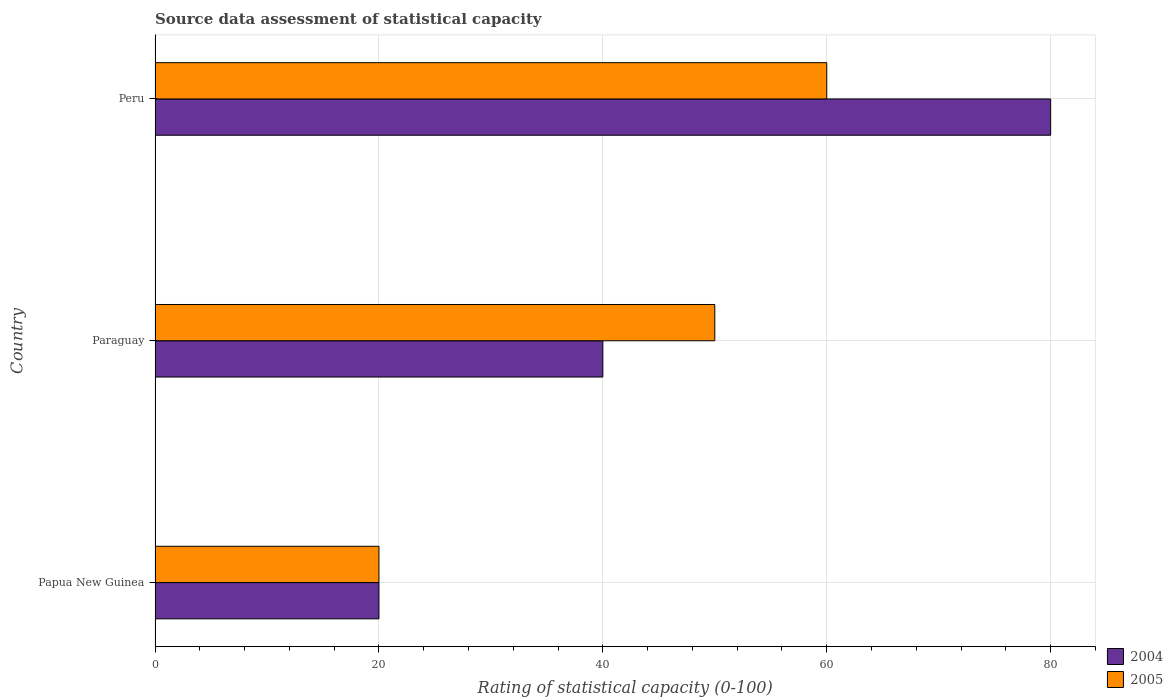How many different coloured bars are there?
Provide a succinct answer. 2. How many groups of bars are there?
Keep it short and to the point. 3. Are the number of bars on each tick of the Y-axis equal?
Your answer should be very brief. Yes. How many bars are there on the 2nd tick from the bottom?
Offer a terse response. 2. In how many cases, is the number of bars for a given country not equal to the number of legend labels?
Give a very brief answer. 0. What is the rating of statistical capacity in 2004 in Peru?
Offer a terse response. 80. Across all countries, what is the maximum rating of statistical capacity in 2005?
Offer a terse response. 60. In which country was the rating of statistical capacity in 2005 minimum?
Offer a very short reply. Papua New Guinea. What is the total rating of statistical capacity in 2005 in the graph?
Ensure brevity in your answer.  130. What is the difference between the rating of statistical capacity in 2004 in Papua New Guinea and that in Peru?
Provide a short and direct response. -60. What is the difference between the rating of statistical capacity in 2005 in Paraguay and the rating of statistical capacity in 2004 in Papua New Guinea?
Make the answer very short. 30. What is the average rating of statistical capacity in 2005 per country?
Offer a terse response. 43.33. What is the ratio of the rating of statistical capacity in 2005 in Paraguay to that in Peru?
Make the answer very short. 0.83. What is the difference between the highest and the second highest rating of statistical capacity in 2005?
Your answer should be compact. 10. In how many countries, is the rating of statistical capacity in 2004 greater than the average rating of statistical capacity in 2004 taken over all countries?
Make the answer very short. 1. What does the 1st bar from the bottom in Paraguay represents?
Provide a succinct answer. 2004. How many bars are there?
Make the answer very short. 6. What is the difference between two consecutive major ticks on the X-axis?
Ensure brevity in your answer.  20. Are the values on the major ticks of X-axis written in scientific E-notation?
Your response must be concise. No. Does the graph contain any zero values?
Your response must be concise. No. Where does the legend appear in the graph?
Provide a short and direct response. Bottom right. How many legend labels are there?
Provide a short and direct response. 2. What is the title of the graph?
Offer a terse response. Source data assessment of statistical capacity. Does "1988" appear as one of the legend labels in the graph?
Make the answer very short. No. What is the label or title of the X-axis?
Your answer should be compact. Rating of statistical capacity (0-100). What is the label or title of the Y-axis?
Offer a very short reply. Country. What is the Rating of statistical capacity (0-100) of 2004 in Papua New Guinea?
Your response must be concise. 20. What is the Rating of statistical capacity (0-100) in 2005 in Papua New Guinea?
Provide a short and direct response. 20. What is the Rating of statistical capacity (0-100) in 2004 in Paraguay?
Your answer should be compact. 40. What is the Rating of statistical capacity (0-100) of 2005 in Paraguay?
Give a very brief answer. 50. What is the total Rating of statistical capacity (0-100) of 2004 in the graph?
Provide a succinct answer. 140. What is the total Rating of statistical capacity (0-100) of 2005 in the graph?
Provide a succinct answer. 130. What is the difference between the Rating of statistical capacity (0-100) of 2005 in Papua New Guinea and that in Paraguay?
Offer a terse response. -30. What is the difference between the Rating of statistical capacity (0-100) of 2004 in Papua New Guinea and that in Peru?
Your response must be concise. -60. What is the difference between the Rating of statistical capacity (0-100) in 2005 in Paraguay and that in Peru?
Make the answer very short. -10. What is the difference between the Rating of statistical capacity (0-100) in 2004 in Papua New Guinea and the Rating of statistical capacity (0-100) in 2005 in Paraguay?
Your response must be concise. -30. What is the average Rating of statistical capacity (0-100) of 2004 per country?
Give a very brief answer. 46.67. What is the average Rating of statistical capacity (0-100) in 2005 per country?
Your answer should be very brief. 43.33. What is the difference between the Rating of statistical capacity (0-100) in 2004 and Rating of statistical capacity (0-100) in 2005 in Papua New Guinea?
Make the answer very short. 0. What is the ratio of the Rating of statistical capacity (0-100) in 2004 in Papua New Guinea to that in Paraguay?
Provide a short and direct response. 0.5. What is the ratio of the Rating of statistical capacity (0-100) in 2004 in Papua New Guinea to that in Peru?
Provide a succinct answer. 0.25. What is the difference between the highest and the second highest Rating of statistical capacity (0-100) of 2004?
Give a very brief answer. 40. 